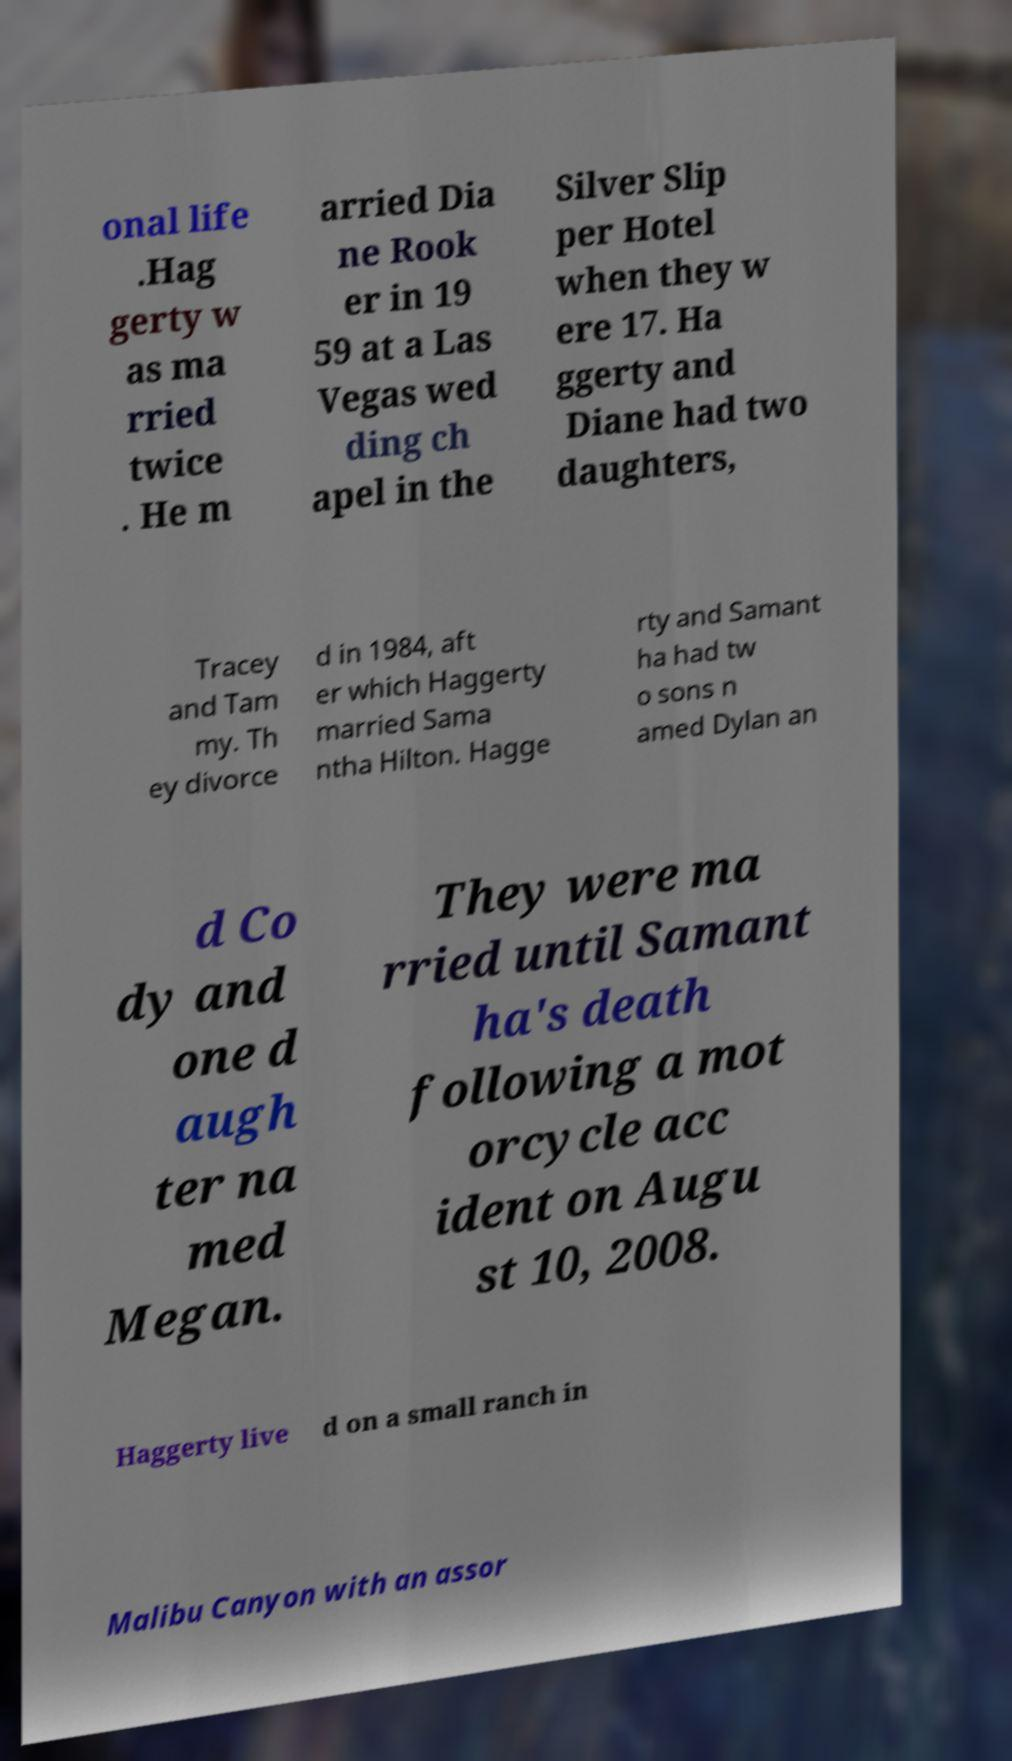Can you read and provide the text displayed in the image?This photo seems to have some interesting text. Can you extract and type it out for me? onal life .Hag gerty w as ma rried twice . He m arried Dia ne Rook er in 19 59 at a Las Vegas wed ding ch apel in the Silver Slip per Hotel when they w ere 17. Ha ggerty and Diane had two daughters, Tracey and Tam my. Th ey divorce d in 1984, aft er which Haggerty married Sama ntha Hilton. Hagge rty and Samant ha had tw o sons n amed Dylan an d Co dy and one d augh ter na med Megan. They were ma rried until Samant ha's death following a mot orcycle acc ident on Augu st 10, 2008. Haggerty live d on a small ranch in Malibu Canyon with an assor 